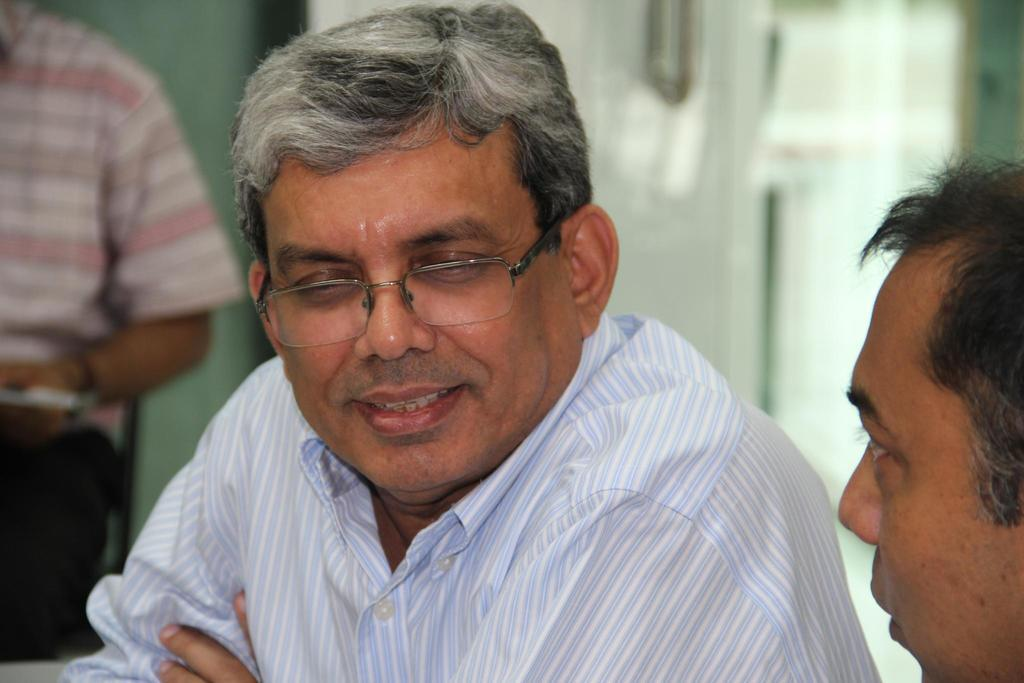What is the main subject of the image? There is a man with spectacles in the image. How many other people are in the image? There are two other persons in the image. Can you describe the background of the image? The background of the image is blurry. What type of street can be seen in the image? There is no street visible in the image. Is there any indication of the season in the image? The provided facts do not mention any seasonal details, so it cannot be determined from the image. 